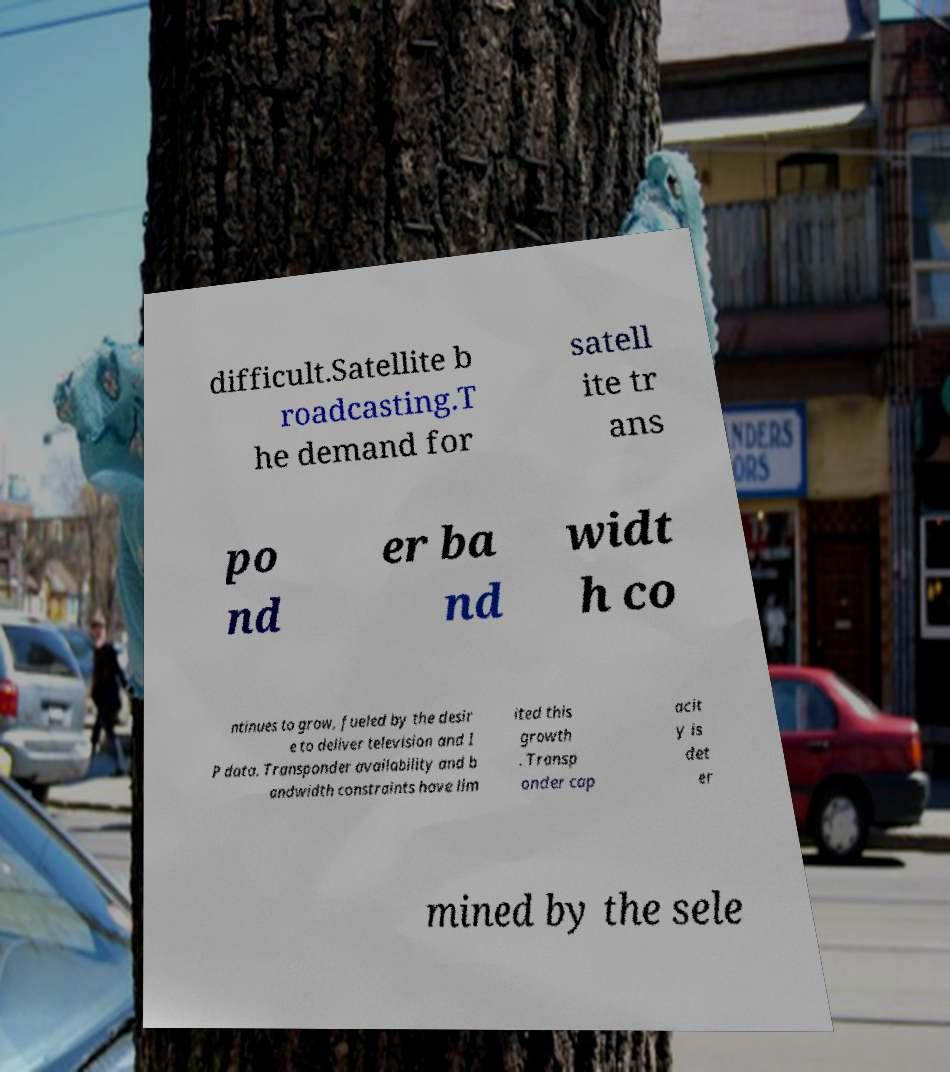For documentation purposes, I need the text within this image transcribed. Could you provide that? difficult.Satellite b roadcasting.T he demand for satell ite tr ans po nd er ba nd widt h co ntinues to grow, fueled by the desir e to deliver television and I P data. Transponder availability and b andwidth constraints have lim ited this growth . Transp onder cap acit y is det er mined by the sele 